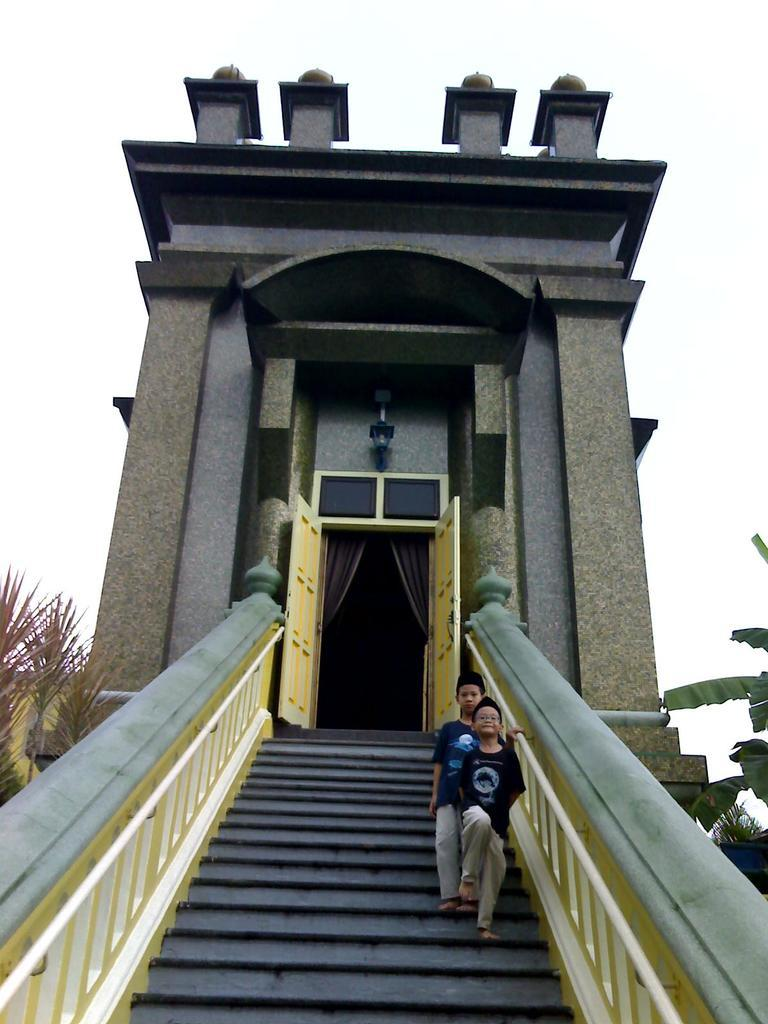What type of structure is present in the image? There is a building in the image. What feature of the building is mentioned in the facts? There is a door in the building. What architectural element can be seen at the bottom of the image? There are stairs at the bottom of the image. Who is visible in the image? There are kids visible in the image. What can be seen in the background of the image? There are trees and the sky visible in the background of the image. What type of wire is being used by the kids to jump in the image? There is no wire present in the image, and the kids are not jumping. What type of milk is being served to the kids in the image? There is no milk present in the image. 